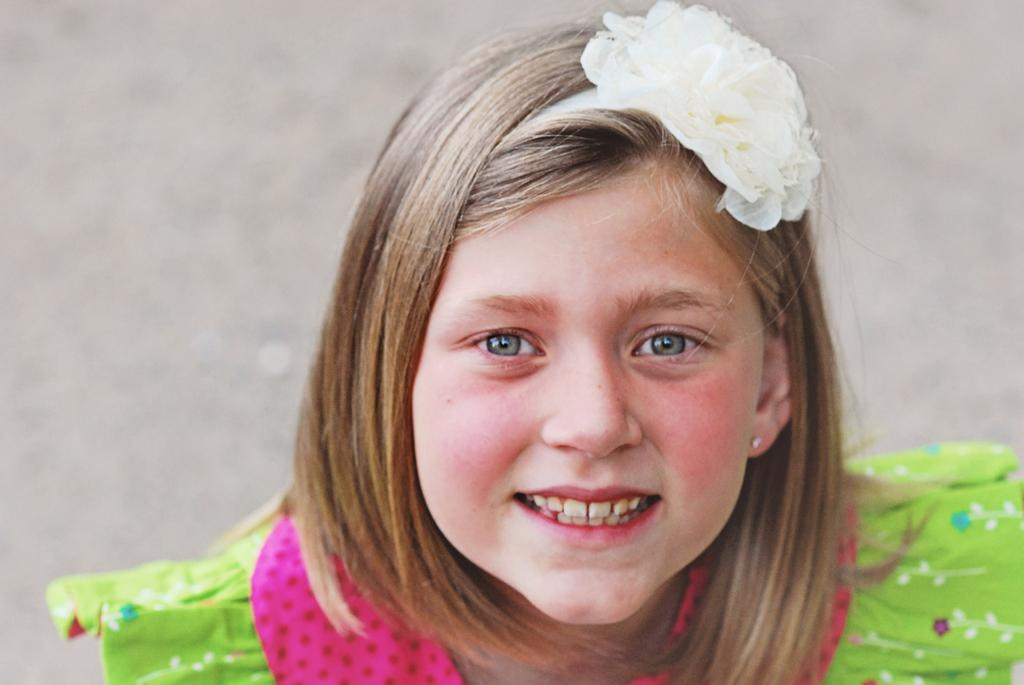Who is the main subject in the image? There is a girl in the image. What is the girl doing in the image? The girl is smiling in the image. What is the girl wearing in the image? The girl is wearing a green dress in the image. What type of channel can be seen in the image? There is no channel present in the image; it features a girl who is smiling and wearing a green dress. How many beads are visible on the girl's dress in the image? There is no mention of beads on the girl's dress in the image; it only states that she is wearing a green dress. 